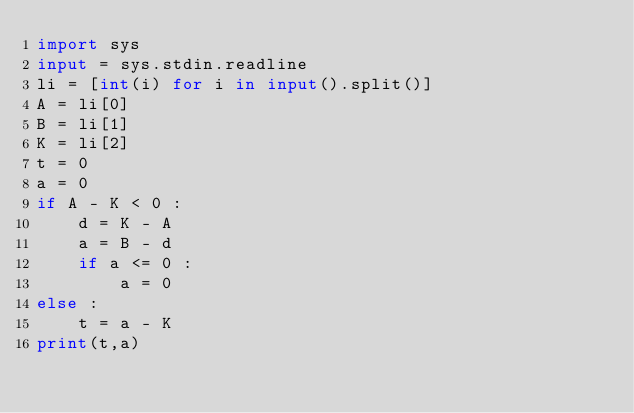Convert code to text. <code><loc_0><loc_0><loc_500><loc_500><_Python_>import sys
input = sys.stdin.readline
li = [int(i) for i in input().split()]
A = li[0]
B = li[1]
K = li[2]
t = 0
a = 0
if A - K < 0 :
    d = K - A
    a = B - d
    if a <= 0 :
        a = 0
else :
    t = a - K
print(t,a)</code> 